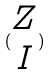<formula> <loc_0><loc_0><loc_500><loc_500>( \begin{matrix} Z \\ I \end{matrix} )</formula> 